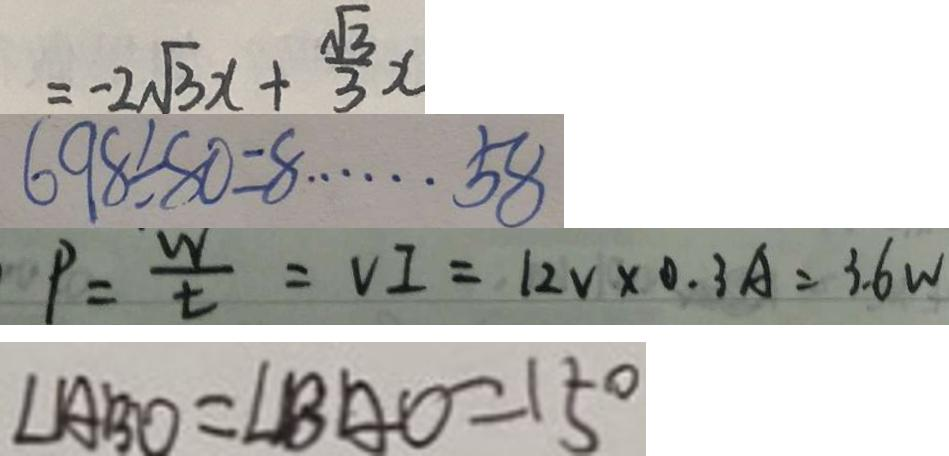Convert formula to latex. <formula><loc_0><loc_0><loc_500><loc_500>= - 2 \sqrt { 3 } x + \frac { \sqrt { 3 } } { 3 } x 
 6 9 8 \div 8 0 = 8 \cdots 5 8 
 P = \frac { w } { t } = V I = 1 2 v \times 0 . 3 A = 3 . 6 W 
 \angle A B O = \angle B A O = 1 5 ^ { \circ }</formula> 